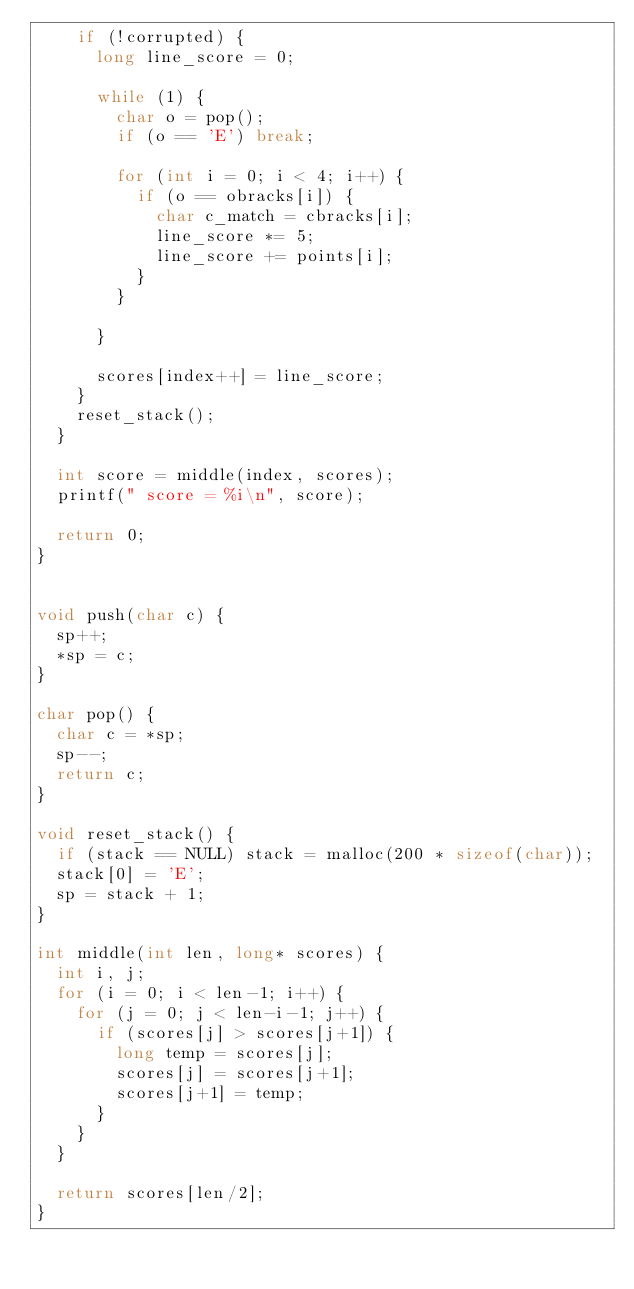<code> <loc_0><loc_0><loc_500><loc_500><_C_>		if (!corrupted) {
			long line_score = 0;

			while (1) {
				char o = pop();
				if (o == 'E') break;

				for (int i = 0; i < 4; i++) {
					if (o == obracks[i]) {
						char c_match = cbracks[i]; 
						line_score *= 5;
						line_score += points[i];
					}
				}

			}

			scores[index++] = line_score;
		}
		reset_stack();
	}

	int score = middle(index, scores);
	printf(" score = %i\n", score);

	return 0;
}


void push(char c) {
	sp++;
	*sp = c;
} 

char pop() {
	char c = *sp;
	sp--;
	return c;
}

void reset_stack() {
	if (stack == NULL) stack = malloc(200 * sizeof(char));
	stack[0] = 'E';
	sp = stack + 1;
}

int middle(int len, long* scores) {
	int i, j;
	for (i = 0; i < len-1; i++) {
		for (j = 0; j < len-i-1; j++) {
			if (scores[j] > scores[j+1]) {
				long temp = scores[j];
				scores[j] = scores[j+1];
				scores[j+1] = temp;
			}
		}
	}

	return scores[len/2];
}
</code> 